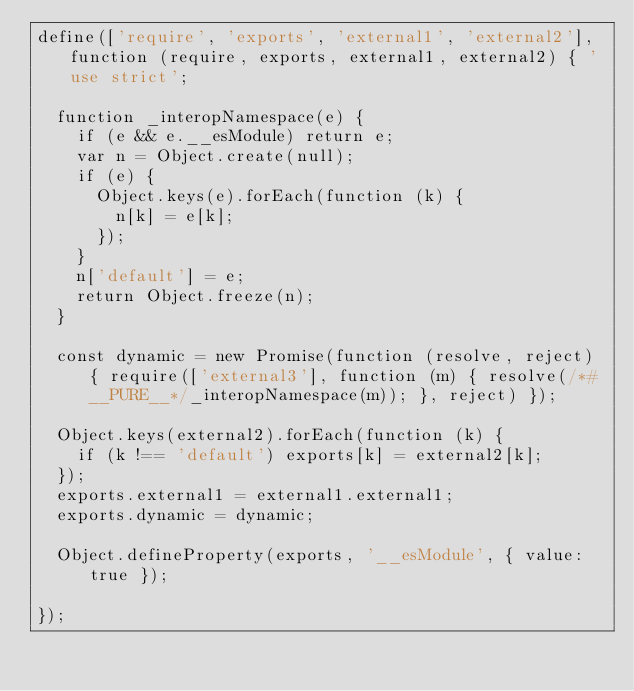<code> <loc_0><loc_0><loc_500><loc_500><_JavaScript_>define(['require', 'exports', 'external1', 'external2'], function (require, exports, external1, external2) { 'use strict';

	function _interopNamespace(e) {
		if (e && e.__esModule) return e;
		var n = Object.create(null);
		if (e) {
			Object.keys(e).forEach(function (k) {
				n[k] = e[k];
			});
		}
		n['default'] = e;
		return Object.freeze(n);
	}

	const dynamic = new Promise(function (resolve, reject) { require(['external3'], function (m) { resolve(/*#__PURE__*/_interopNamespace(m)); }, reject) });

	Object.keys(external2).forEach(function (k) {
		if (k !== 'default') exports[k] = external2[k];
	});
	exports.external1 = external1.external1;
	exports.dynamic = dynamic;

	Object.defineProperty(exports, '__esModule', { value: true });

});
</code> 